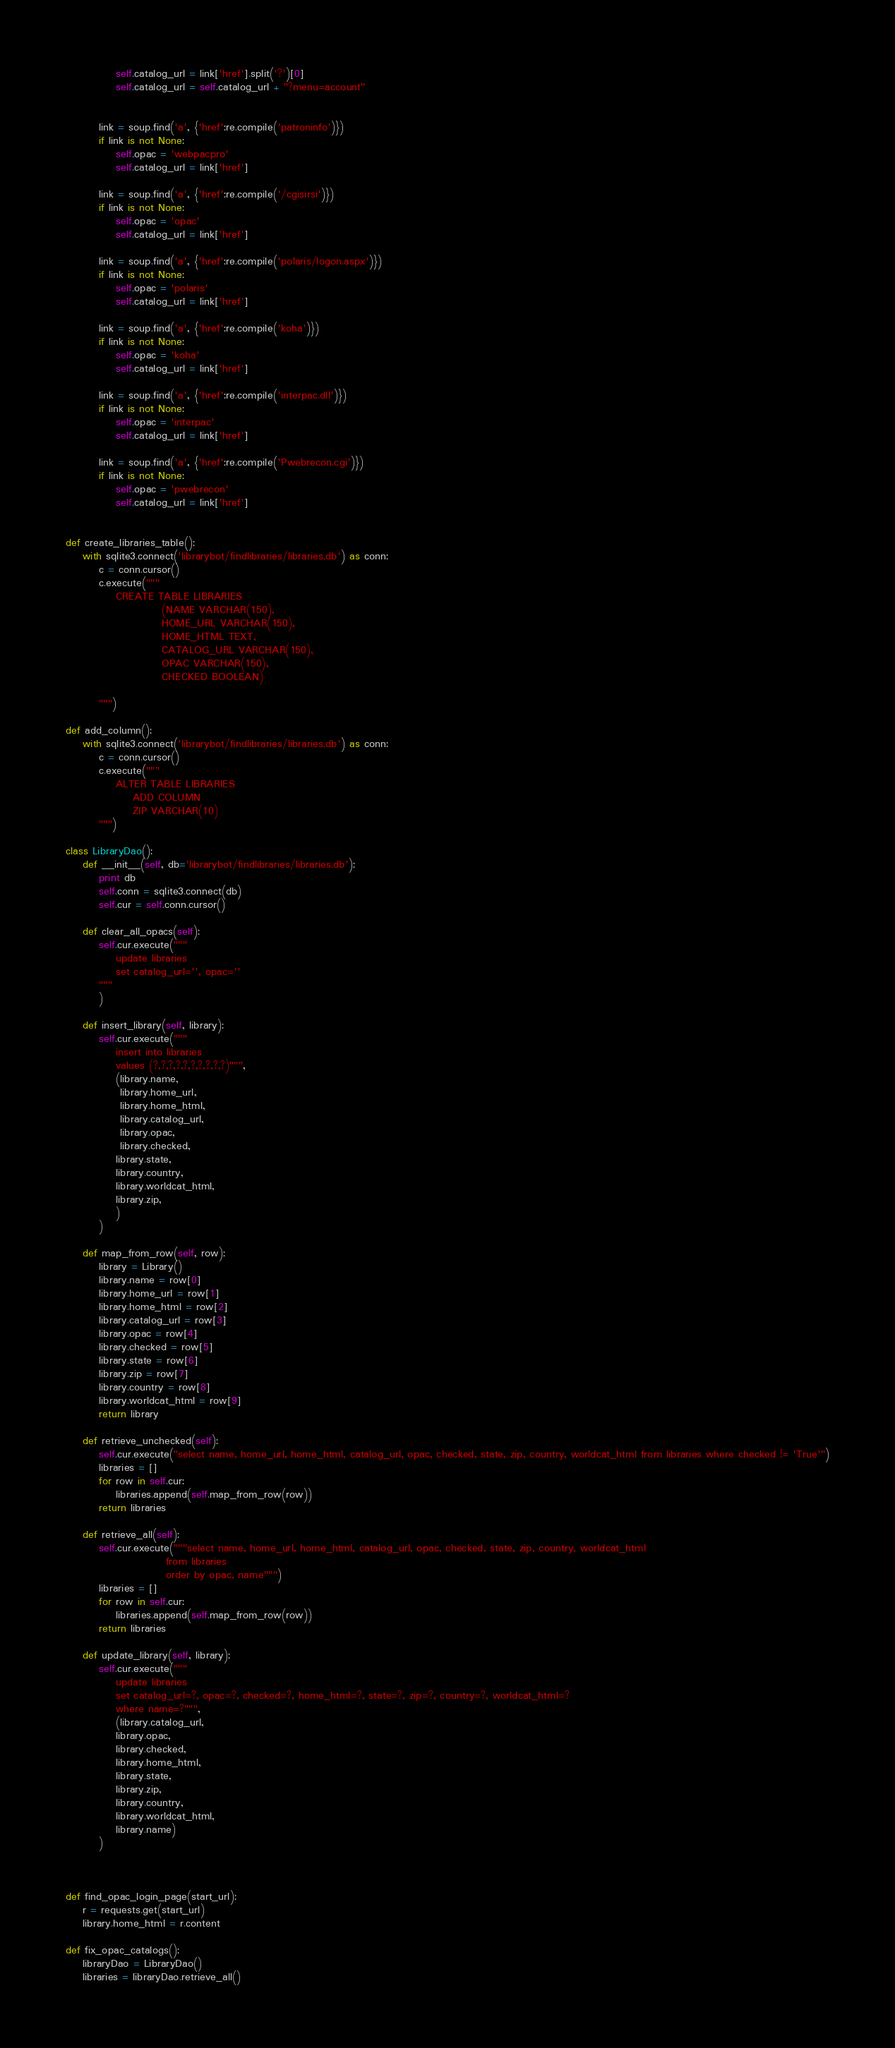Convert code to text. <code><loc_0><loc_0><loc_500><loc_500><_Python_>            self.catalog_url = link['href'].split('?')[0]
            self.catalog_url = self.catalog_url + "?menu=account"


        link = soup.find('a', {'href':re.compile('patroninfo')})
        if link is not None:
            self.opac = 'webpacpro'
            self.catalog_url = link['href']

        link = soup.find('a', {'href':re.compile('/cgisirsi')})
        if link is not None:
            self.opac = 'opac'
            self.catalog_url = link['href']

        link = soup.find('a', {'href':re.compile('polaris/logon.aspx')})
        if link is not None:
            self.opac = 'polaris'
            self.catalog_url = link['href']

        link = soup.find('a', {'href':re.compile('koha')})
        if link is not None:
            self.opac = 'koha'
            self.catalog_url = link['href']

        link = soup.find('a', {'href':re.compile('interpac.dll')})
        if link is not None:
            self.opac = 'interpac'
            self.catalog_url = link['href']

        link = soup.find('a', {'href':re.compile('Pwebrecon.cgi')})
        if link is not None:
            self.opac = 'pwebrecon'
            self.catalog_url = link['href']


def create_libraries_table():
    with sqlite3.connect('librarybot/findlibraries/libraries.db') as conn:
        c = conn.cursor()
        c.execute("""
            CREATE TABLE LIBRARIES
                       (NAME VARCHAR(150),
                       HOME_URL VARCHAR(150),
                       HOME_HTML TEXT,
                       CATALOG_URL VARCHAR(150),
                       OPAC VARCHAR(150),
                       CHECKED BOOLEAN)

        """)

def add_column():
    with sqlite3.connect('librarybot/findlibraries/libraries.db') as conn:
        c = conn.cursor()
        c.execute("""
            ALTER TABLE LIBRARIES
                ADD COLUMN
                ZIP VARCHAR(10)
        """)

class LibraryDao():
    def __init__(self, db='librarybot/findlibraries/libraries.db'):
        print db
        self.conn = sqlite3.connect(db)
        self.cur = self.conn.cursor()

    def clear_all_opacs(self):
        self.cur.execute("""
            update libraries
            set catalog_url='', opac=''
        """
        )

    def insert_library(self, library):
        self.cur.execute("""
            insert into libraries
            values (?,?,?,?,?,?,?,?,?,?)""",
            (library.name,
             library.home_url,
             library.home_html,
             library.catalog_url,
             library.opac,
             library.checked,
            library.state,
            library.country,
            library.worldcat_html,
            library.zip,
            )
        )

    def map_from_row(self, row):
        library = Library()
        library.name = row[0]
        library.home_url = row[1]
        library.home_html = row[2]
        library.catalog_url = row[3]
        library.opac = row[4]
        library.checked = row[5]
        library.state = row[6]
        library.zip = row[7]
        library.country = row[8]
        library.worldcat_html = row[9]
        return library

    def retrieve_unchecked(self):
        self.cur.execute("select name, home_url, home_html, catalog_url, opac, checked, state, zip, country, worldcat_html from libraries where checked != 'True'")
        libraries = []
        for row in self.cur:
            libraries.append(self.map_from_row(row))
        return libraries

    def retrieve_all(self):
        self.cur.execute("""select name, home_url, home_html, catalog_url, opac, checked, state, zip, country, worldcat_html
                        from libraries
                        order by opac, name""")
        libraries = []
        for row in self.cur:
            libraries.append(self.map_from_row(row))
        return libraries

    def update_library(self, library):
        self.cur.execute("""
            update libraries
            set catalog_url=?, opac=?, checked=?, home_html=?, state=?, zip=?, country=?, worldcat_html=?
            where name=?""",
            (library.catalog_url,
            library.opac,
            library.checked,
            library.home_html,
            library.state,
            library.zip,
            library.country,
            library.worldcat_html,
            library.name)
        )



def find_opac_login_page(start_url):
    r = requests.get(start_url)
    library.home_html = r.content

def fix_opac_catalogs():
    libraryDao = LibraryDao()
    libraries = libraryDao.retrieve_all()</code> 